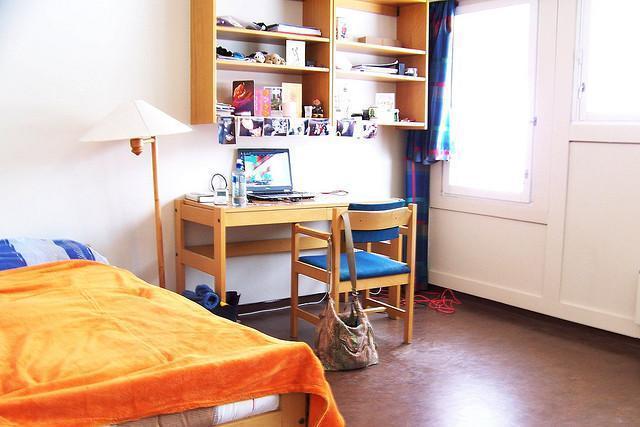How many people are walking toward the building?
Give a very brief answer. 0. 